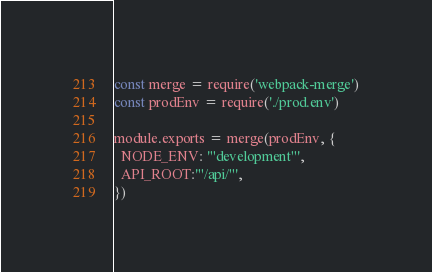Convert code to text. <code><loc_0><loc_0><loc_500><loc_500><_JavaScript_>const merge = require('webpack-merge')
const prodEnv = require('./prod.env')

module.exports = merge(prodEnv, {
  NODE_ENV: '"development"',
  API_ROOT:'"/api/"',
})
</code> 